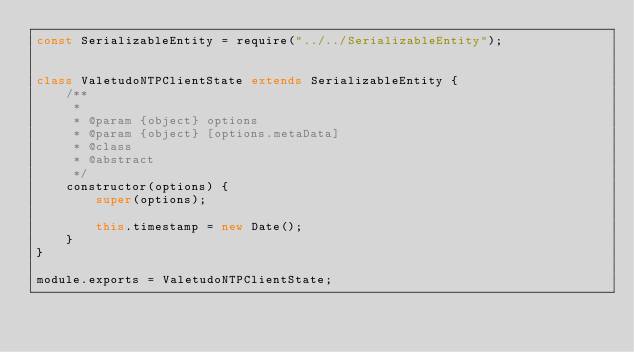<code> <loc_0><loc_0><loc_500><loc_500><_JavaScript_>const SerializableEntity = require("../../SerializableEntity");


class ValetudoNTPClientState extends SerializableEntity {
    /**
     *
     * @param {object} options
     * @param {object} [options.metaData]
     * @class
     * @abstract
     */
    constructor(options) {
        super(options);

        this.timestamp = new Date();
    }
}

module.exports = ValetudoNTPClientState;
</code> 